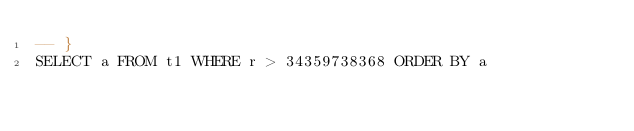<code> <loc_0><loc_0><loc_500><loc_500><_SQL_>-- }
SELECT a FROM t1 WHERE r > 34359738368 ORDER BY a</code> 